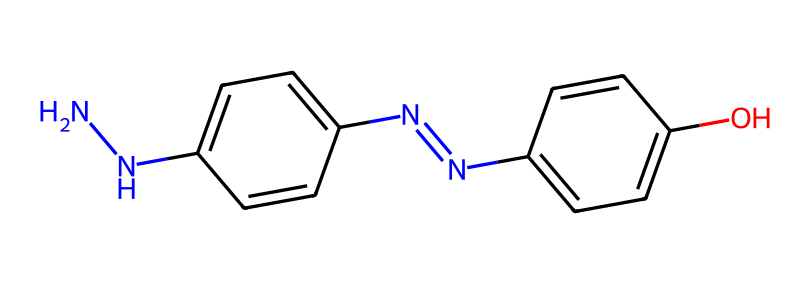What is the primary functional group present in this hydrazine-based dye? The structure contains hydrazine groups (-N-N-), which are characteristic of hydrazines. These groups play a key role in the reactivity and properties of the dye.
Answer: hydrazine How many nitrogen atoms are present in the molecule? By counting the nitrogen atoms in the SMILES representation, we can identify that there are three nitrogen atoms present.
Answer: three What is the total number of benzene rings in the molecule? The molecule features two distinct aromatic rings (benzene) denoted in the structure, each connected by the azo (-N=N-) linkage.
Answer: two What type of reaction might this dye undergo due to its azo group? The azo group is known to undergo azo coupling reactions, where it can react with nucleophiles. This reactivity is significant in dye chemistry for color formation.
Answer: azo coupling What does the '-O' in the structure signify about the dye's properties? The presence of the -O group indicates that there is a hydroxyl (-OH) group, which may enhance solubility in water and contribute to the dye's stability and reactivity.
Answer: hydroxyl group Which element is likely to influence the dye's affinity for yarn? Nitrogen atoms in the hydrazine moiety enhance the dye's interaction with the yarn fibers through hydrogen bonding, affecting its affinity for dyeing.
Answer: nitrogen How many double bonds can be identified in the structure? Evaluating the structure shows two double bonds: one in the azo (-N=N-) linkage and another in the aromatic rings, leading to a total of three double bonds if considering the benzene ring conjugation as well.
Answer: three 